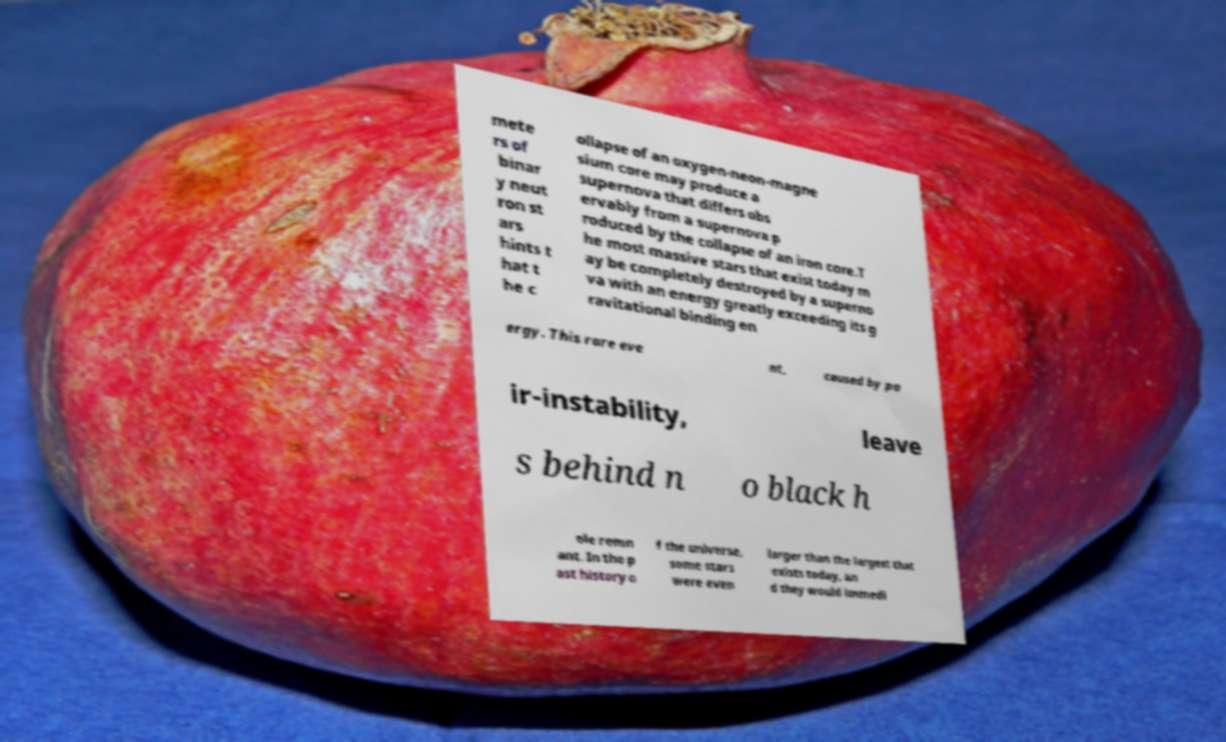Could you extract and type out the text from this image? mete rs of binar y neut ron st ars hints t hat t he c ollapse of an oxygen-neon-magne sium core may produce a supernova that differs obs ervably from a supernova p roduced by the collapse of an iron core.T he most massive stars that exist today m ay be completely destroyed by a superno va with an energy greatly exceeding its g ravitational binding en ergy. This rare eve nt, caused by pa ir-instability, leave s behind n o black h ole remn ant. In the p ast history o f the universe, some stars were even larger than the largest that exists today, an d they would immedi 